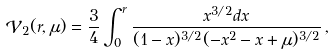Convert formula to latex. <formula><loc_0><loc_0><loc_500><loc_500>\mathcal { V } _ { 2 } ( r , \mu ) = \frac { 3 } { 4 } \int _ { 0 } ^ { r } \frac { x ^ { 3 / 2 } d x } { ( 1 - x ) ^ { 3 / 2 } ( - x ^ { 2 } - x + \mu ) ^ { 3 / 2 } } \, ,</formula> 